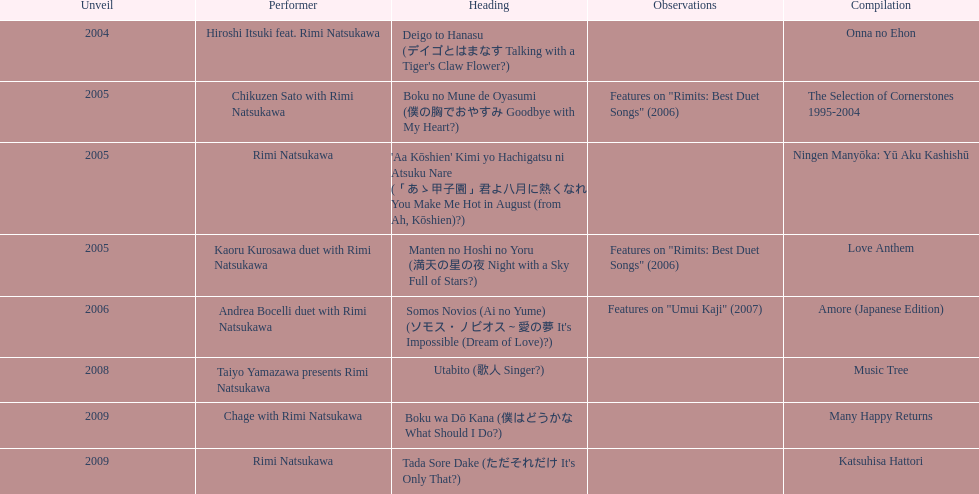What is the last title released? 2009. 